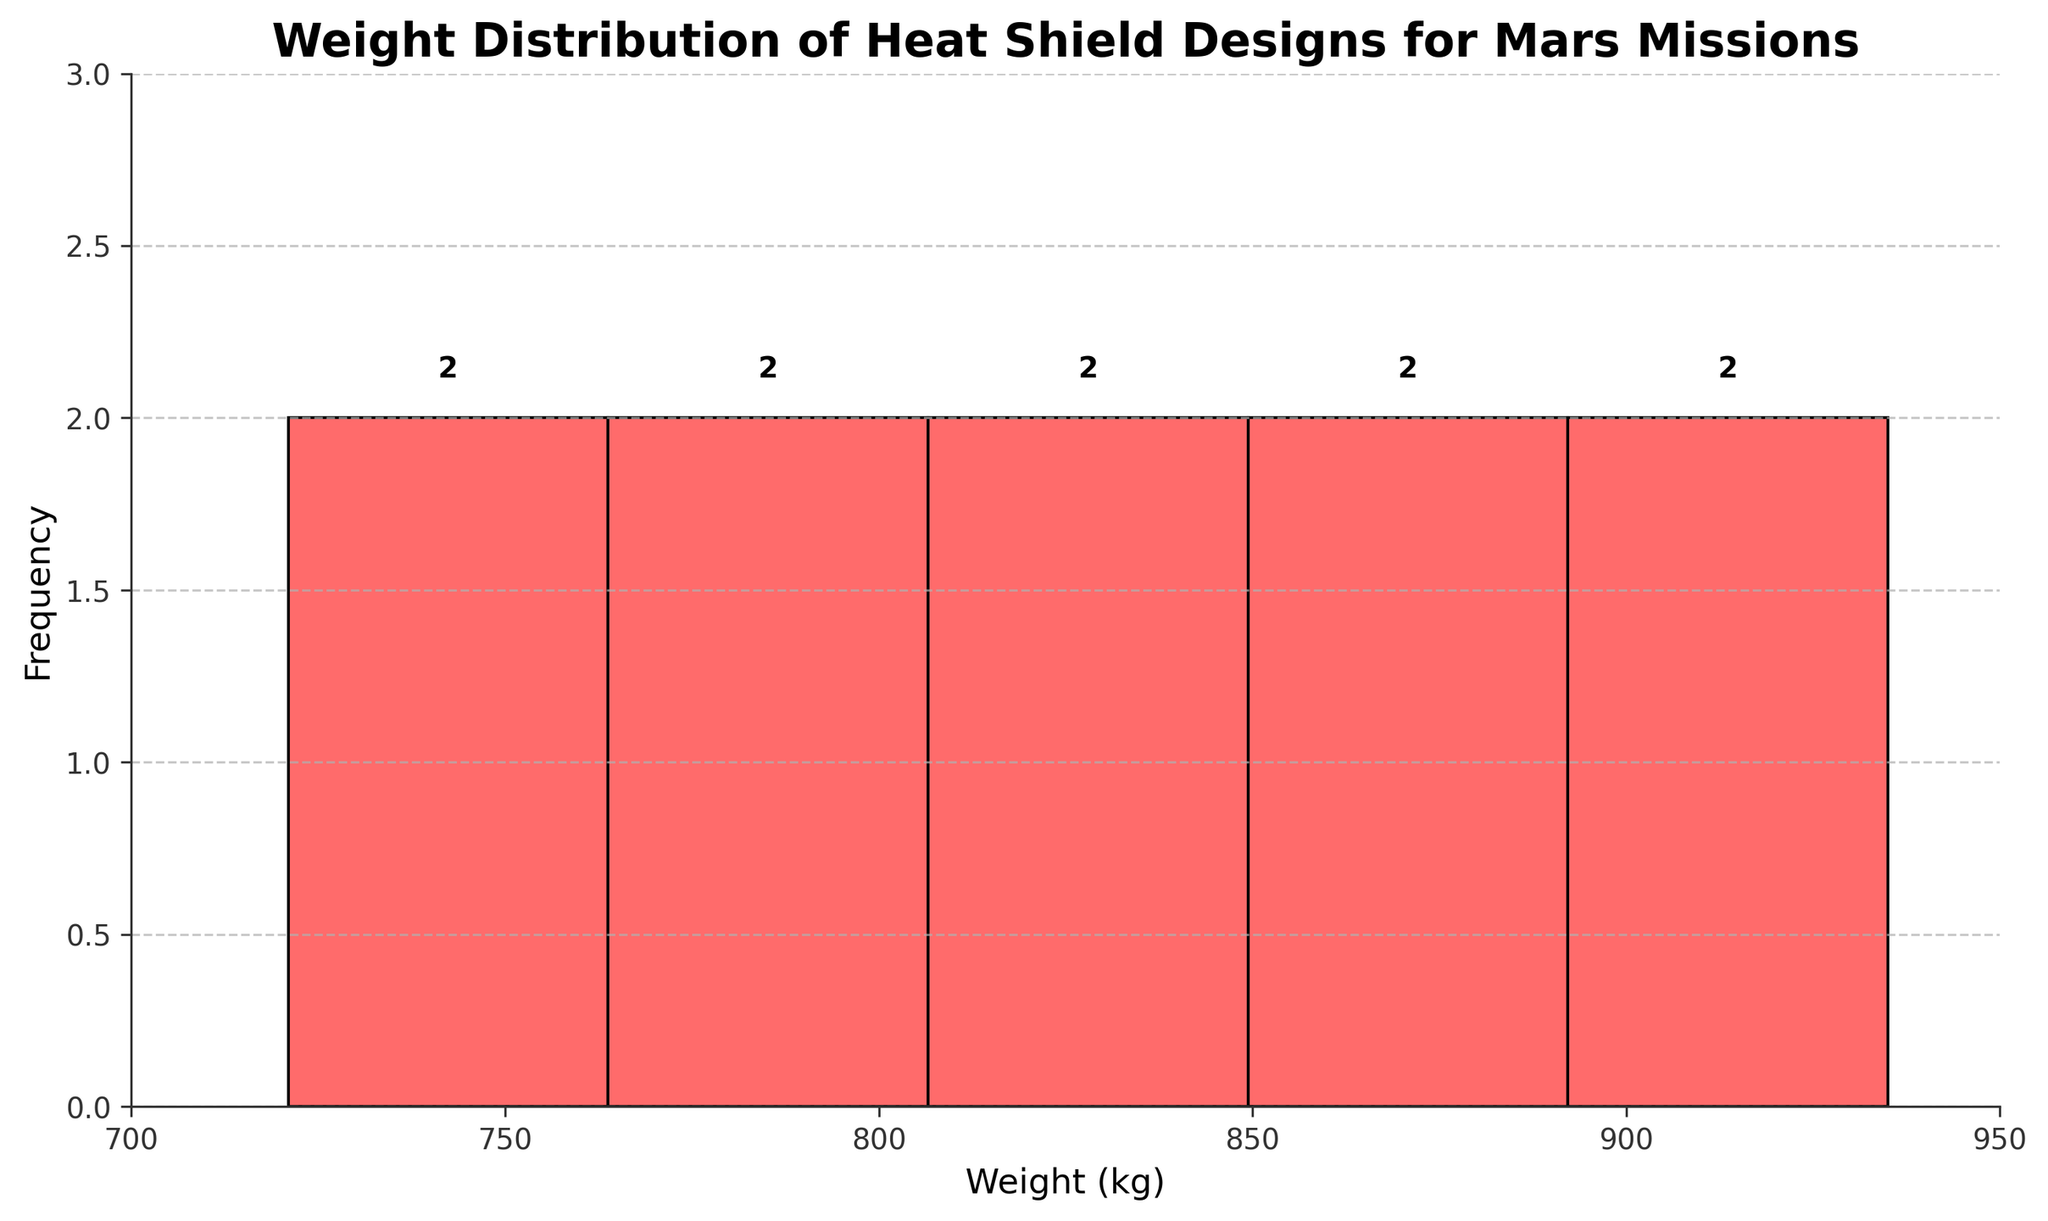What is the title of the histogram? The title of the histogram is displayed at the top of the chart.
Answer: Weight Distribution of Heat Shield Designs for Mars Missions What is the range of weights displayed on the x-axis? The x-axis range can be inferred by looking at the x-ticks and the x-axis limits, which span from 700 to 950 kg.
Answer: 700 to 950 kg How many heat shield designs are represented within the weight range 720-760 kg? The histogram bins categorize the weight data. By observing the count within the bin representing 720-760 kg, we see there are 2 designs.
Answer: 2 Which weight range contains the most heat shield designs? By looking at the frequency bars in the histogram, the tallest bar represents the weight range 880-920 kg.
Answer: 880-920 kg How many total heat shield designs are shown in the histogram? Each bar's height represents the count of designs in different weight ranges. Adding up all the counts gives the total: 1+2+1+3+3 = 10 designs.
Answer: 10 What is the highest recorded frequency in the histogram? The highest frequency is represented by the tallest bar in the histogram. The height of this bar corresponds to 3.
Answer: 3 What is the average weight of the heat shield designs? Calculate the sum of all weights and divide by the number of designs: (848 + 721 + 935 + 892 + 803 + 779 + 912 + 867 + 825 + 756)/10 = 8338/10 = 833.8 kg.
Answer: 833.8 kg What weight range does the PICA-X design fall into? PICA-X has a weight of 848 kg. By checking the histogram, 848 kg falls within the 840-880 kg range.
Answer: 840-880 kg Compare the number of designs in the 700-800 kg range to those in the 800-900 kg range. Sum the frequencies of bins covering 700-800 kg and 800-900 kg: 700-800 kg has 1+2=3 designs, while 800-900 kg has 1+3=4 designs. Thus, there are fewer designs in the 700-800 kg range compared to the 800-900 kg range.
Answer: 700-800 kg has fewer designs What's the median weight of the heat shield designs? To find the median, list all weights in ascending order and locate the middle value: 721, 756, 779, 803, 825, 848, 867, 892, 912, 935. The middle values are 825 and 848, so the median is (825+848)/2 = 836.5 kg.
Answer: 836.5 kg 